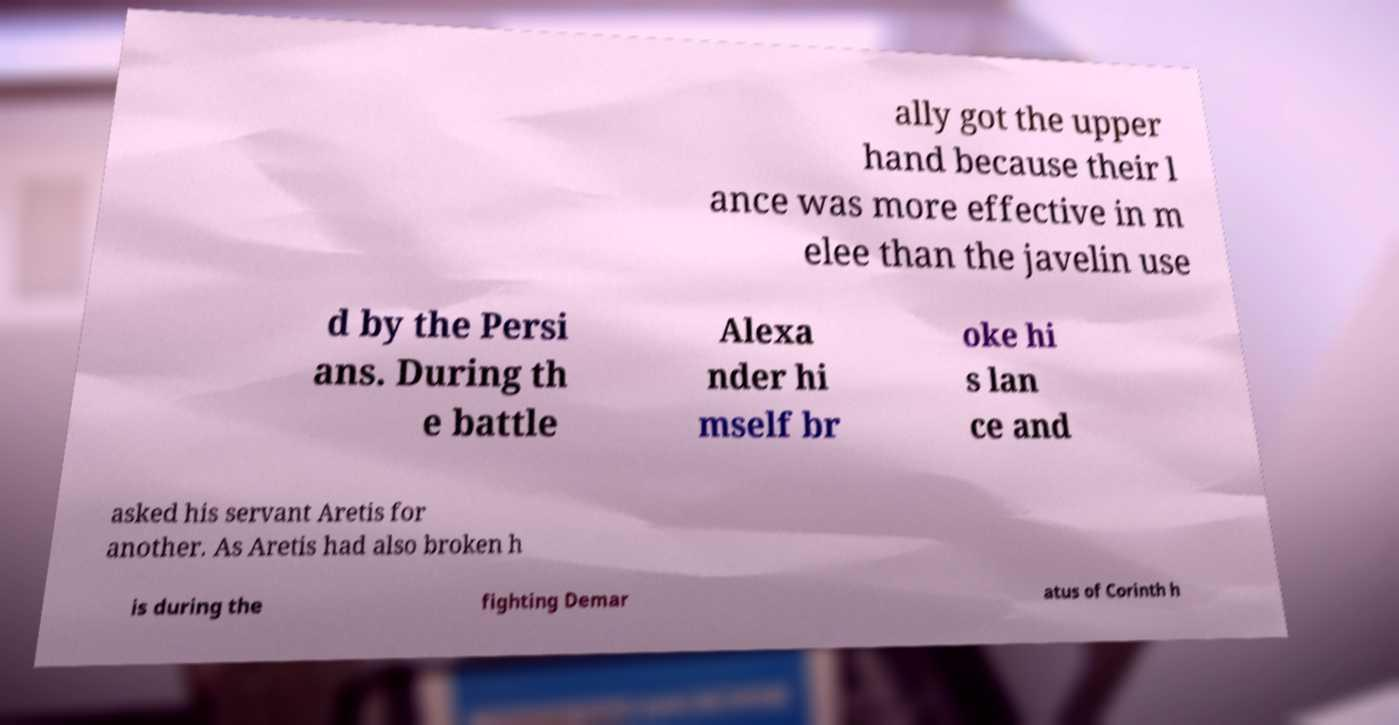What messages or text are displayed in this image? I need them in a readable, typed format. ally got the upper hand because their l ance was more effective in m elee than the javelin use d by the Persi ans. During th e battle Alexa nder hi mself br oke hi s lan ce and asked his servant Aretis for another. As Aretis had also broken h is during the fighting Demar atus of Corinth h 